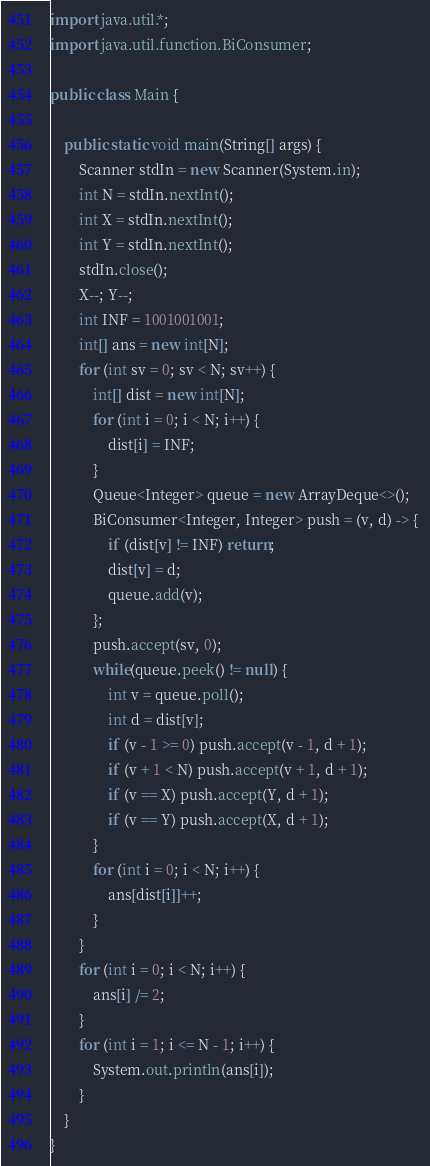Convert code to text. <code><loc_0><loc_0><loc_500><loc_500><_Java_>import java.util.*;
import java.util.function.BiConsumer;
 
public class Main {
 
    public static void main(String[] args) {
        Scanner stdIn = new Scanner(System.in);
        int N = stdIn.nextInt();    
        int X = stdIn.nextInt();    
        int Y = stdIn.nextInt();    
        stdIn.close();
        X--; Y--;
        int INF = 1001001001;
        int[] ans = new int[N];
        for (int sv = 0; sv < N; sv++) {
            int[] dist = new int[N];
            for (int i = 0; i < N; i++) {
                dist[i] = INF;
            }
            Queue<Integer> queue = new ArrayDeque<>();
            BiConsumer<Integer, Integer> push = (v, d) -> { 
                if (dist[v] != INF) return;
                dist[v] = d;
                queue.add(v);
            };
            push.accept(sv, 0);
            while(queue.peek() != null) {
                int v = queue.poll();
                int d = dist[v];
                if (v - 1 >= 0) push.accept(v - 1, d + 1);
                if (v + 1 < N) push.accept(v + 1, d + 1);
                if (v == X) push.accept(Y, d + 1);
                if (v == Y) push.accept(X, d + 1);
            }
            for (int i = 0; i < N; i++) {
                ans[dist[i]]++;
            }
        }
        for (int i = 0; i < N; i++) {
            ans[i] /= 2;
        }
        for (int i = 1; i <= N - 1; i++) {
            System.out.println(ans[i]);        
        }
    }
}</code> 